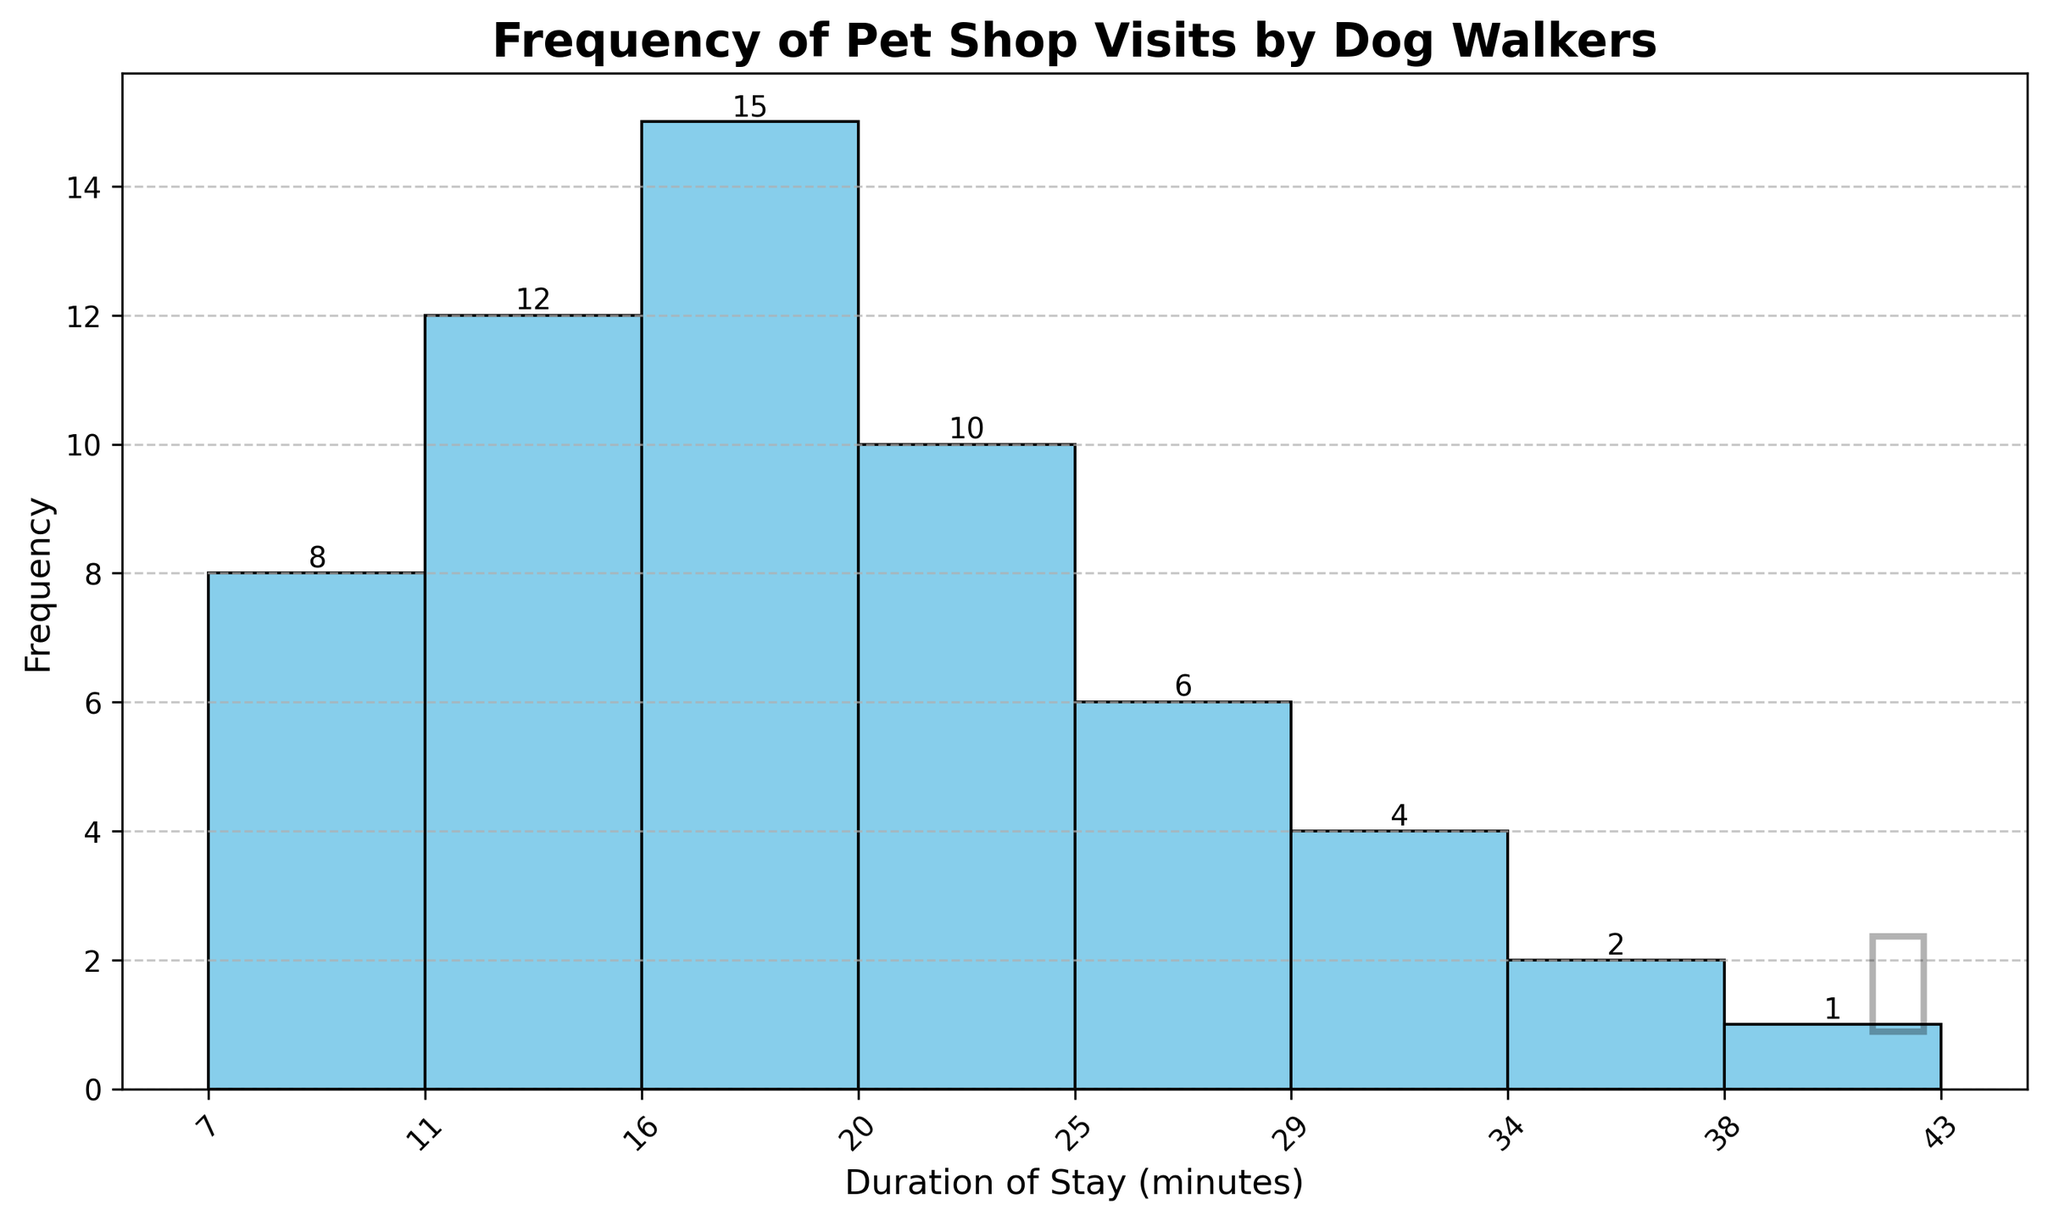What is the title of the histogram? The title is usually placed at the top of the chart to describe what is being shown. In the histogram, it is "Frequency of Pet Shop Visits by Dog Walkers".
Answer: Frequency of Pet Shop Visits by Dog Walkers What are the units on the x-axis? The x-axis labels tell us what the units are. They represent the duration of stay (in minutes) at the pet shop by dog walkers.
Answer: Duration of Stay (minutes) Which duration range has the highest frequency of visits? Look at the bar with the greatest height to find this value. The bar corresponding to the 16-20 minutes duration range has the highest frequency.
Answer: 16-20 minutes How many total visits are depicted in the histogram? Sum the heights of all the bars representing the frequencies. These frequencies are 8, 12, 15, 10, 6, 4, 2, 1. Therefore, the total visits are \(8 + 12 + 15 + 10 + 6 + 4 + 2 + 1 = 58\).
Answer: 58 What is the range of the x-axis? The x-axis range can be determined by looking at the lowest and highest ticks on the x-axis. It ranges from 5 to 45 minutes.
Answer: 5 to 45 minutes How does the frequency of visits change as the duration of stay increases? Observe the pattern in the height of the bars from left to right. Initially, frequencies increase, peaking at 16-20 minutes, then gradually decrease for longer durations.
Answer: Increases then decreases Which duration category has the lowest frequency of visits? Refer to the bar with the smallest height. The category with a frequency of 1 represents the 41-45 minutes duration range.
Answer: 41-45 minutes What is the second most frequent duration range for pet shop visits? The highest frequency bar is for 16-20 minutes. The second tallest bar is for the 11-15 minutes range, which has a frequency of 12.
Answer: 11-15 minutes How many visit durations have a frequency of 10 or higher? Identify and count the bars with a frequency of 10 or more. These are the bars for 11-15, 16-20, and 21-25 minute ranges. Therefore, there are 3 such durations.
Answer: 3 